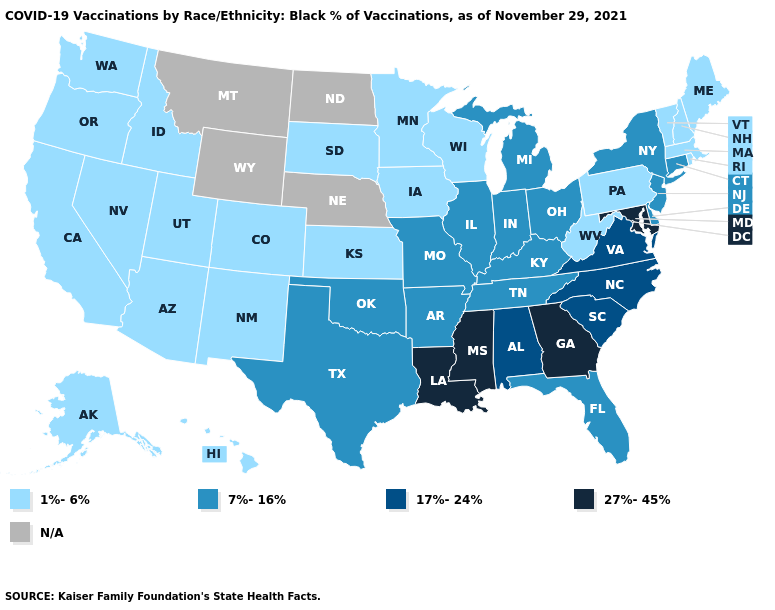Name the states that have a value in the range 27%-45%?
Give a very brief answer. Georgia, Louisiana, Maryland, Mississippi. Among the states that border Washington , which have the highest value?
Concise answer only. Idaho, Oregon. What is the value of Georgia?
Concise answer only. 27%-45%. Name the states that have a value in the range 1%-6%?
Quick response, please. Alaska, Arizona, California, Colorado, Hawaii, Idaho, Iowa, Kansas, Maine, Massachusetts, Minnesota, Nevada, New Hampshire, New Mexico, Oregon, Pennsylvania, Rhode Island, South Dakota, Utah, Vermont, Washington, West Virginia, Wisconsin. What is the value of Alaska?
Quick response, please. 1%-6%. Name the states that have a value in the range 17%-24%?
Be succinct. Alabama, North Carolina, South Carolina, Virginia. Name the states that have a value in the range 17%-24%?
Give a very brief answer. Alabama, North Carolina, South Carolina, Virginia. Name the states that have a value in the range 17%-24%?
Keep it brief. Alabama, North Carolina, South Carolina, Virginia. Which states have the lowest value in the USA?
Keep it brief. Alaska, Arizona, California, Colorado, Hawaii, Idaho, Iowa, Kansas, Maine, Massachusetts, Minnesota, Nevada, New Hampshire, New Mexico, Oregon, Pennsylvania, Rhode Island, South Dakota, Utah, Vermont, Washington, West Virginia, Wisconsin. Which states have the lowest value in the South?
Short answer required. West Virginia. What is the value of North Dakota?
Write a very short answer. N/A. What is the highest value in the Northeast ?
Answer briefly. 7%-16%. 